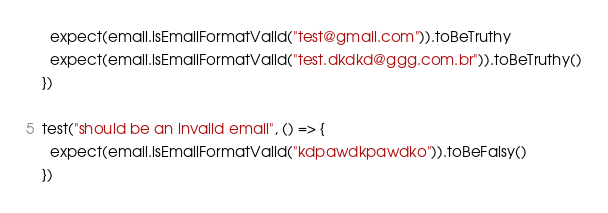<code> <loc_0><loc_0><loc_500><loc_500><_TypeScript_>  expect(email.isEmailFormatValid("test@gmail.com")).toBeTruthy
  expect(email.isEmailFormatValid("test.dkdkd@ggg.com.br")).toBeTruthy()
})

test("should be an invalid email", () => {
  expect(email.isEmailFormatValid("kdpawdkpawdko")).toBeFalsy()
})
</code> 